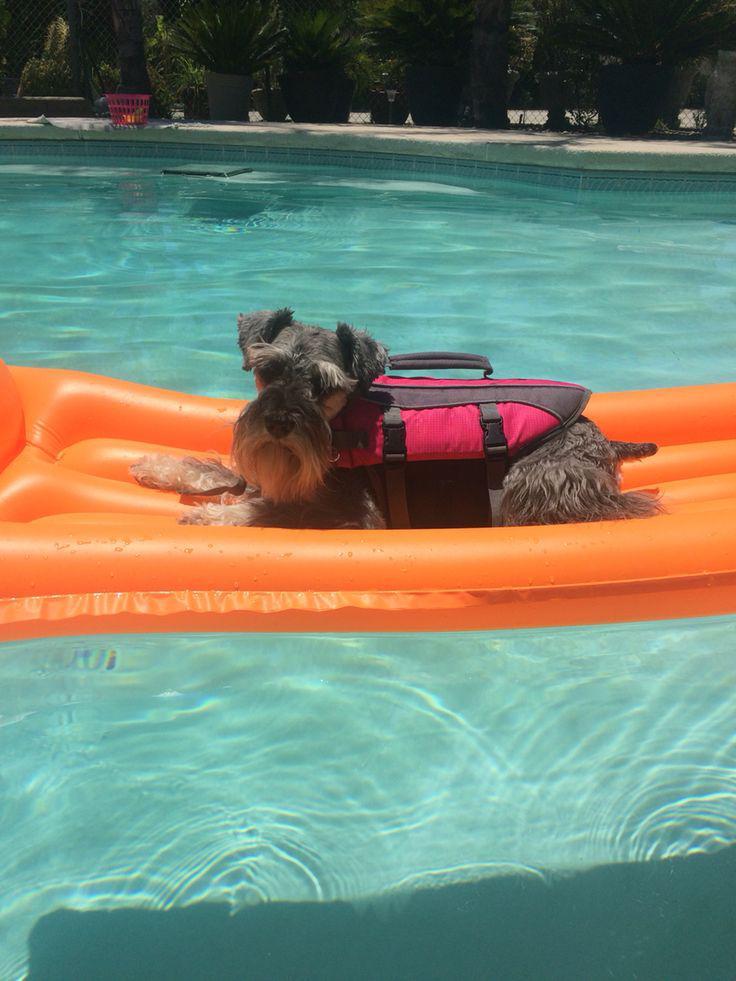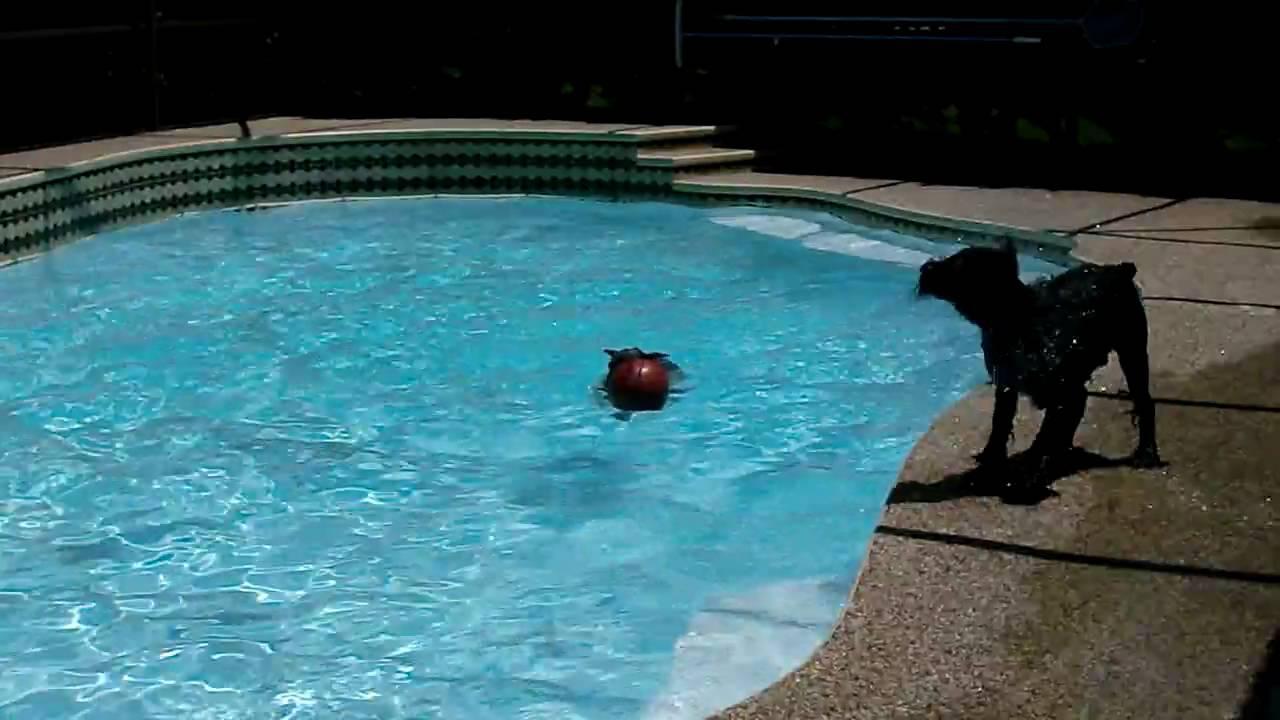The first image is the image on the left, the second image is the image on the right. Analyze the images presented: Is the assertion "There are at least four dogs in the pool." valid? Answer yes or no. No. The first image is the image on the left, the second image is the image on the right. Analyze the images presented: Is the assertion "At least one dog is in an inner tube." valid? Answer yes or no. No. 